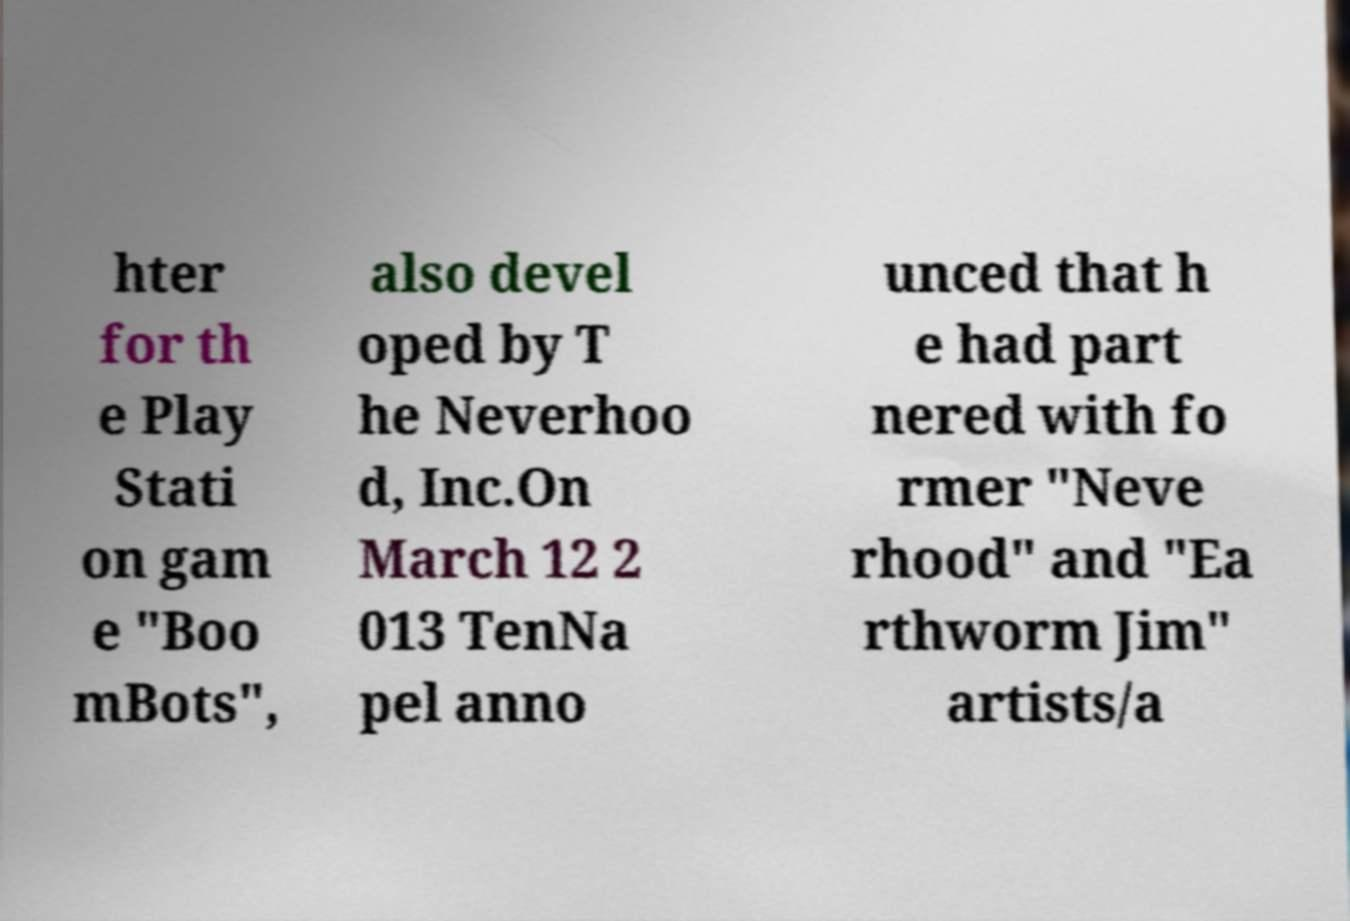Can you read and provide the text displayed in the image?This photo seems to have some interesting text. Can you extract and type it out for me? hter for th e Play Stati on gam e "Boo mBots", also devel oped by T he Neverhoo d, Inc.On March 12 2 013 TenNa pel anno unced that h e had part nered with fo rmer "Neve rhood" and "Ea rthworm Jim" artists/a 